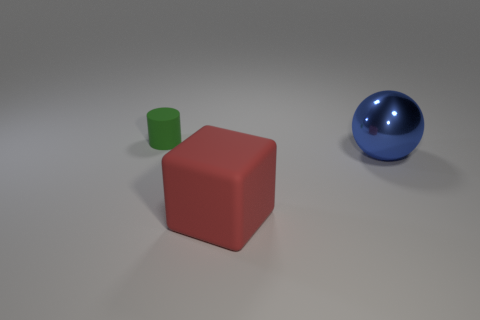Add 3 tiny green cylinders. How many objects exist? 6 Subtract all spheres. How many objects are left? 2 Add 1 big blue rubber cylinders. How many big blue rubber cylinders exist? 1 Subtract 0 yellow cubes. How many objects are left? 3 Subtract all cubes. Subtract all tiny things. How many objects are left? 1 Add 3 blue balls. How many blue balls are left? 4 